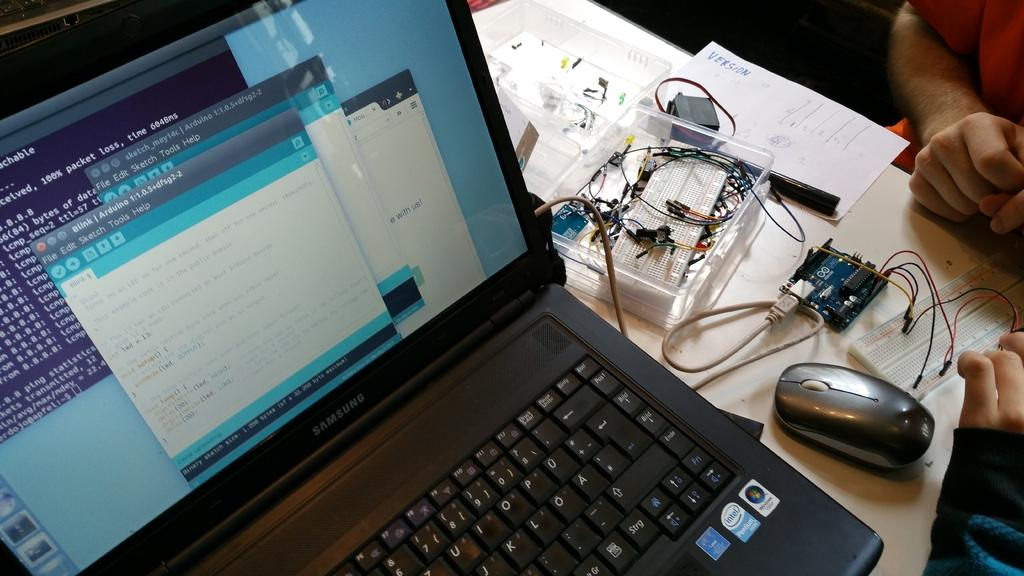<image>
Describe the image concisely. A Blink page open on a laptop with File, Edit, Sketch, Tools, and Help, available on the screen. 